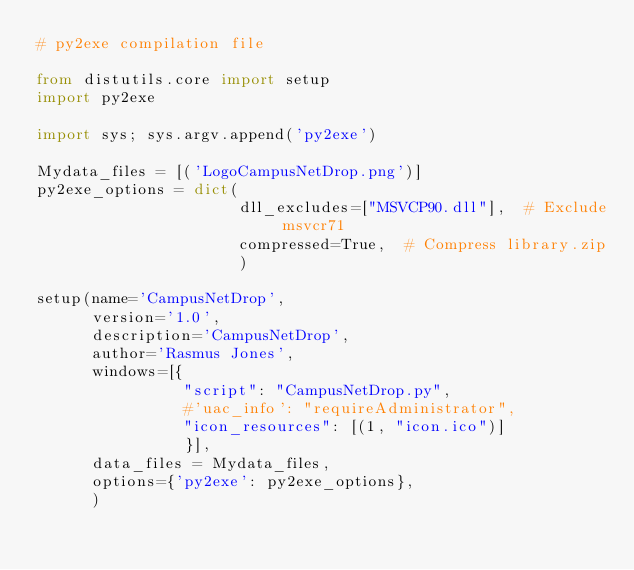<code> <loc_0><loc_0><loc_500><loc_500><_Python_># py2exe compilation file

from distutils.core import setup
import py2exe

import sys; sys.argv.append('py2exe')

Mydata_files = [('LogoCampusNetDrop.png')]
py2exe_options = dict(
                      dll_excludes=["MSVCP90.dll"],  # Exclude msvcr71
                      compressed=True,  # Compress library.zip
                      )

setup(name='CampusNetDrop',
      version='1.0',
      description='CampusNetDrop',
      author='Rasmus Jones',
      windows=[{
      			"script": "CampusNetDrop.py",
      			#'uac_info': "requireAdministrator",
      			"icon_resources": [(1, "icon.ico")]
      			}],
      data_files = Mydata_files,
      options={'py2exe': py2exe_options},
      )</code> 